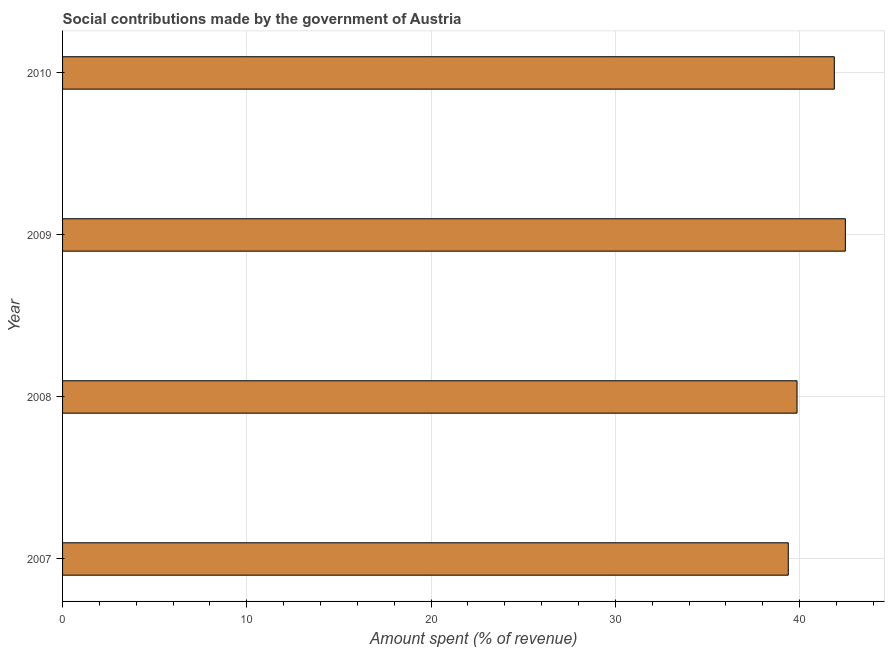Does the graph contain grids?
Provide a succinct answer. Yes. What is the title of the graph?
Keep it short and to the point. Social contributions made by the government of Austria. What is the label or title of the X-axis?
Provide a succinct answer. Amount spent (% of revenue). What is the label or title of the Y-axis?
Ensure brevity in your answer.  Year. What is the amount spent in making social contributions in 2008?
Keep it short and to the point. 39.86. Across all years, what is the maximum amount spent in making social contributions?
Offer a terse response. 42.48. Across all years, what is the minimum amount spent in making social contributions?
Your answer should be very brief. 39.39. What is the sum of the amount spent in making social contributions?
Keep it short and to the point. 163.62. What is the difference between the amount spent in making social contributions in 2008 and 2009?
Your answer should be very brief. -2.62. What is the average amount spent in making social contributions per year?
Keep it short and to the point. 40.91. What is the median amount spent in making social contributions?
Your response must be concise. 40.87. Do a majority of the years between 2009 and 2010 (inclusive) have amount spent in making social contributions greater than 42 %?
Keep it short and to the point. No. What is the ratio of the amount spent in making social contributions in 2007 to that in 2009?
Provide a short and direct response. 0.93. Is the amount spent in making social contributions in 2007 less than that in 2009?
Provide a succinct answer. Yes. Is the difference between the amount spent in making social contributions in 2007 and 2009 greater than the difference between any two years?
Provide a short and direct response. Yes. What is the difference between the highest and the second highest amount spent in making social contributions?
Offer a terse response. 0.6. Is the sum of the amount spent in making social contributions in 2007 and 2010 greater than the maximum amount spent in making social contributions across all years?
Make the answer very short. Yes. What is the difference between the highest and the lowest amount spent in making social contributions?
Keep it short and to the point. 3.1. How many bars are there?
Provide a succinct answer. 4. How many years are there in the graph?
Your answer should be compact. 4. What is the Amount spent (% of revenue) in 2007?
Your response must be concise. 39.39. What is the Amount spent (% of revenue) in 2008?
Provide a succinct answer. 39.86. What is the Amount spent (% of revenue) of 2009?
Make the answer very short. 42.48. What is the Amount spent (% of revenue) of 2010?
Keep it short and to the point. 41.89. What is the difference between the Amount spent (% of revenue) in 2007 and 2008?
Your answer should be compact. -0.48. What is the difference between the Amount spent (% of revenue) in 2007 and 2009?
Your answer should be very brief. -3.1. What is the difference between the Amount spent (% of revenue) in 2007 and 2010?
Provide a short and direct response. -2.5. What is the difference between the Amount spent (% of revenue) in 2008 and 2009?
Your answer should be compact. -2.62. What is the difference between the Amount spent (% of revenue) in 2008 and 2010?
Make the answer very short. -2.02. What is the difference between the Amount spent (% of revenue) in 2009 and 2010?
Provide a short and direct response. 0.6. What is the ratio of the Amount spent (% of revenue) in 2007 to that in 2009?
Offer a terse response. 0.93. What is the ratio of the Amount spent (% of revenue) in 2008 to that in 2009?
Your response must be concise. 0.94. What is the ratio of the Amount spent (% of revenue) in 2008 to that in 2010?
Offer a very short reply. 0.95. What is the ratio of the Amount spent (% of revenue) in 2009 to that in 2010?
Ensure brevity in your answer.  1.01. 